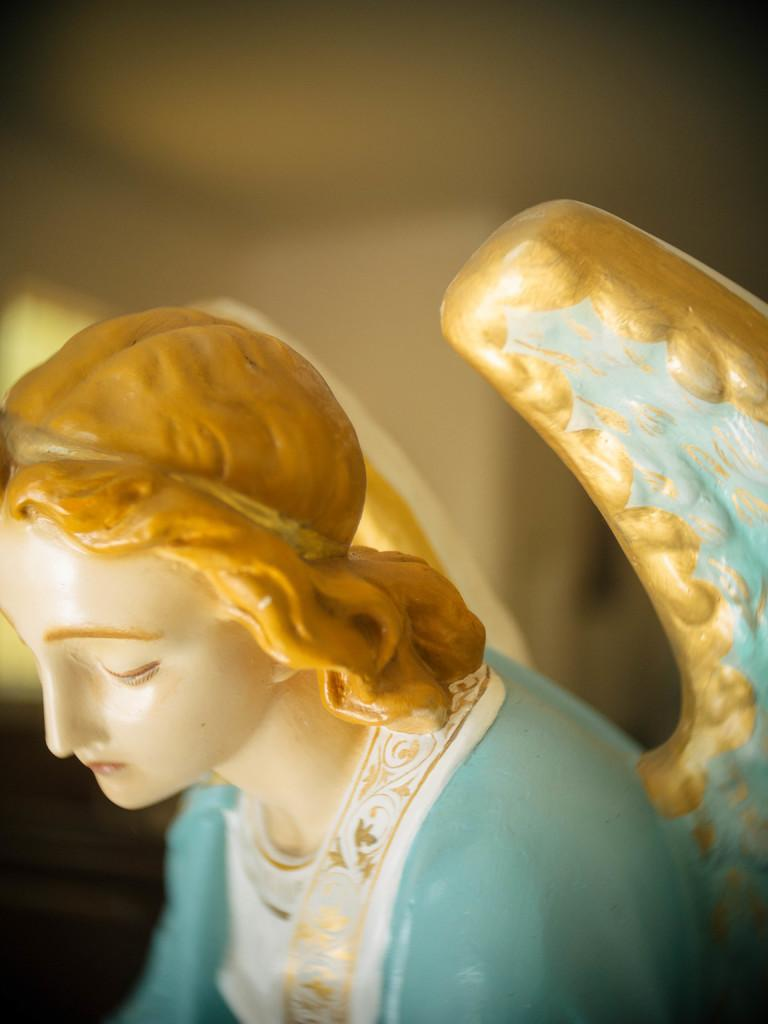What is the main subject of the image? There is a sculpture of an angel in the image. What type of quill is the angel holding in the image? There is no quill present in the image; the sculpture of the angel does not have any visible objects in its hands. 